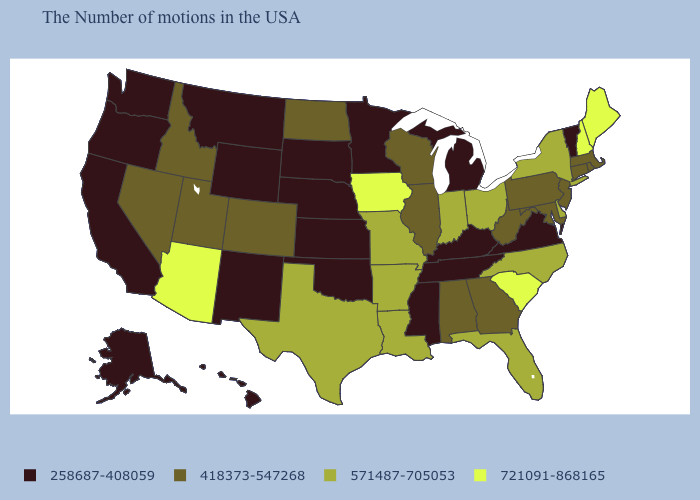Among the states that border Nebraska , which have the highest value?
Answer briefly. Iowa. Name the states that have a value in the range 418373-547268?
Write a very short answer. Massachusetts, Rhode Island, Connecticut, New Jersey, Maryland, Pennsylvania, West Virginia, Georgia, Alabama, Wisconsin, Illinois, North Dakota, Colorado, Utah, Idaho, Nevada. Name the states that have a value in the range 258687-408059?
Answer briefly. Vermont, Virginia, Michigan, Kentucky, Tennessee, Mississippi, Minnesota, Kansas, Nebraska, Oklahoma, South Dakota, Wyoming, New Mexico, Montana, California, Washington, Oregon, Alaska, Hawaii. What is the lowest value in the USA?
Concise answer only. 258687-408059. What is the value of Ohio?
Keep it brief. 571487-705053. What is the value of Tennessee?
Keep it brief. 258687-408059. Name the states that have a value in the range 418373-547268?
Be succinct. Massachusetts, Rhode Island, Connecticut, New Jersey, Maryland, Pennsylvania, West Virginia, Georgia, Alabama, Wisconsin, Illinois, North Dakota, Colorado, Utah, Idaho, Nevada. Name the states that have a value in the range 571487-705053?
Short answer required. New York, Delaware, North Carolina, Ohio, Florida, Indiana, Louisiana, Missouri, Arkansas, Texas. What is the lowest value in the USA?
Answer briefly. 258687-408059. What is the value of New York?
Short answer required. 571487-705053. Name the states that have a value in the range 418373-547268?
Quick response, please. Massachusetts, Rhode Island, Connecticut, New Jersey, Maryland, Pennsylvania, West Virginia, Georgia, Alabama, Wisconsin, Illinois, North Dakota, Colorado, Utah, Idaho, Nevada. Among the states that border West Virginia , does Ohio have the highest value?
Keep it brief. Yes. Which states have the lowest value in the MidWest?
Keep it brief. Michigan, Minnesota, Kansas, Nebraska, South Dakota. Does the first symbol in the legend represent the smallest category?
Quick response, please. Yes. What is the value of Arizona?
Write a very short answer. 721091-868165. 